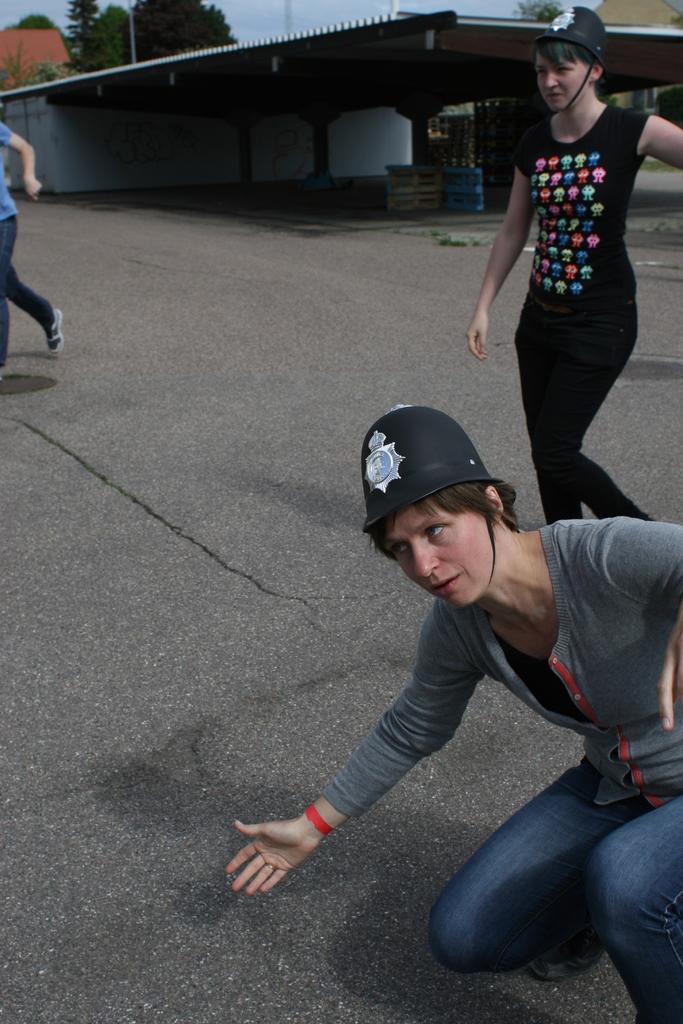Can you describe this image briefly? In this picture we can see there are two persons walking on the road and a person is in squat position. Behind the three persons there is a shed, houses, trees and the sky. 